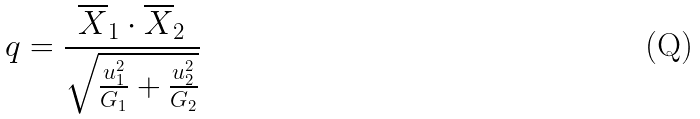<formula> <loc_0><loc_0><loc_500><loc_500>q = \frac { \overline { X } _ { 1 } \cdot \overline { X } _ { 2 } } { \sqrt { \frac { u _ { 1 } ^ { 2 } } { G _ { 1 } } + \frac { u _ { 2 } ^ { 2 } } { G _ { 2 } } } }</formula> 